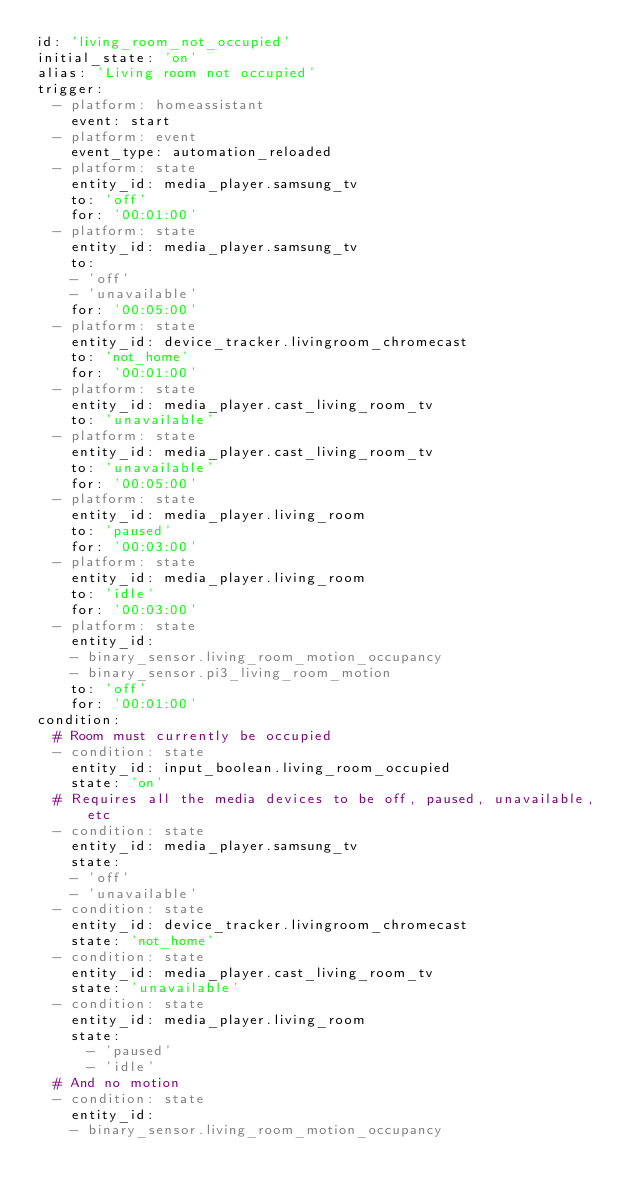<code> <loc_0><loc_0><loc_500><loc_500><_YAML_>id: 'living_room_not_occupied'
initial_state: 'on'
alias: 'Living room not occupied'
trigger:
  - platform: homeassistant
    event: start
  - platform: event
    event_type: automation_reloaded
  - platform: state
    entity_id: media_player.samsung_tv
    to: 'off'
    for: '00:01:00'
  - platform: state
    entity_id: media_player.samsung_tv
    to: 
    - 'off'
    - 'unavailable'
    for: '00:05:00'
  - platform: state
    entity_id: device_tracker.livingroom_chromecast
    to: 'not_home'
    for: '00:01:00'
  - platform: state
    entity_id: media_player.cast_living_room_tv
    to: 'unavailable'
  - platform: state
    entity_id: media_player.cast_living_room_tv
    to: 'unavailable'
    for: '00:05:00'
  - platform: state
    entity_id: media_player.living_room
    to: 'paused'
    for: '00:03:00'
  - platform: state
    entity_id: media_player.living_room
    to: 'idle'
    for: '00:03:00'
  - platform: state
    entity_id: 
    - binary_sensor.living_room_motion_occupancy
    - binary_sensor.pi3_living_room_motion
    to: 'off'
    for: '00:01:00'
condition:
  # Room must currently be occupied
  - condition: state
    entity_id: input_boolean.living_room_occupied
    state: 'on'
  # Requires all the media devices to be off, paused, unavailable, etc
  - condition: state
    entity_id: media_player.samsung_tv
    state: 
    - 'off'
    - 'unavailable'
  - condition: state
    entity_id: device_tracker.livingroom_chromecast
    state: 'not_home'
  - condition: state
    entity_id: media_player.cast_living_room_tv
    state: 'unavailable'
  - condition: state
    entity_id: media_player.living_room
    state: 
      - 'paused'
      - 'idle'
  # And no motion
  - condition: state
    entity_id: 
    - binary_sensor.living_room_motion_occupancy</code> 